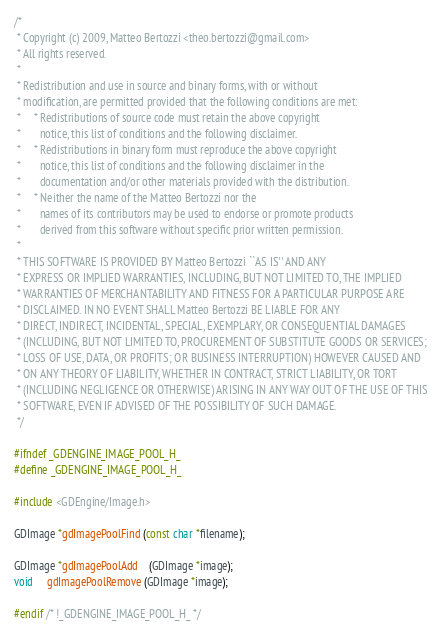<code> <loc_0><loc_0><loc_500><loc_500><_C_>/*
 * Copyright (c) 2009, Matteo Bertozzi <theo.bertozzi@gmail.com>
 * All rights reserved.
 *
 * Redistribution and use in source and binary forms, with or without
 * modification, are permitted provided that the following conditions are met:
 *     * Redistributions of source code must retain the above copyright
 *       notice, this list of conditions and the following disclaimer.
 *     * Redistributions in binary form must reproduce the above copyright
 *       notice, this list of conditions and the following disclaimer in the
 *       documentation and/or other materials provided with the distribution.
 *     * Neither the name of the Matteo Bertozzi nor the
 *       names of its contributors may be used to endorse or promote products
 *       derived from this software without specific prior written permission.
 *
 * THIS SOFTWARE IS PROVIDED BY Matteo Bertozzi ``AS IS'' AND ANY
 * EXPRESS OR IMPLIED WARRANTIES, INCLUDING, BUT NOT LIMITED TO, THE IMPLIED
 * WARRANTIES OF MERCHANTABILITY AND FITNESS FOR A PARTICULAR PURPOSE ARE
 * DISCLAIMED. IN NO EVENT SHALL Matteo Bertozzi BE LIABLE FOR ANY
 * DIRECT, INDIRECT, INCIDENTAL, SPECIAL, EXEMPLARY, OR CONSEQUENTIAL DAMAGES
 * (INCLUDING, BUT NOT LIMITED TO, PROCUREMENT OF SUBSTITUTE GOODS OR SERVICES;
 * LOSS OF USE, DATA, OR PROFITS; OR BUSINESS INTERRUPTION) HOWEVER CAUSED AND
 * ON ANY THEORY OF LIABILITY, WHETHER IN CONTRACT, STRICT LIABILITY, OR TORT
 * (INCLUDING NEGLIGENCE OR OTHERWISE) ARISING IN ANY WAY OUT OF THE USE OF THIS
 * SOFTWARE, EVEN IF ADVISED OF THE POSSIBILITY OF SUCH DAMAGE.
 */

#ifndef _GDENGINE_IMAGE_POOL_H_
#define _GDENGINE_IMAGE_POOL_H_

#include <GDEngine/Image.h>

GDImage *gdImagePoolFind (const char *filename);

GDImage *gdImagePoolAdd    (GDImage *image);
void     gdImagePoolRemove (GDImage *image);

#endif /* !_GDENGINE_IMAGE_POOL_H_ */

</code> 